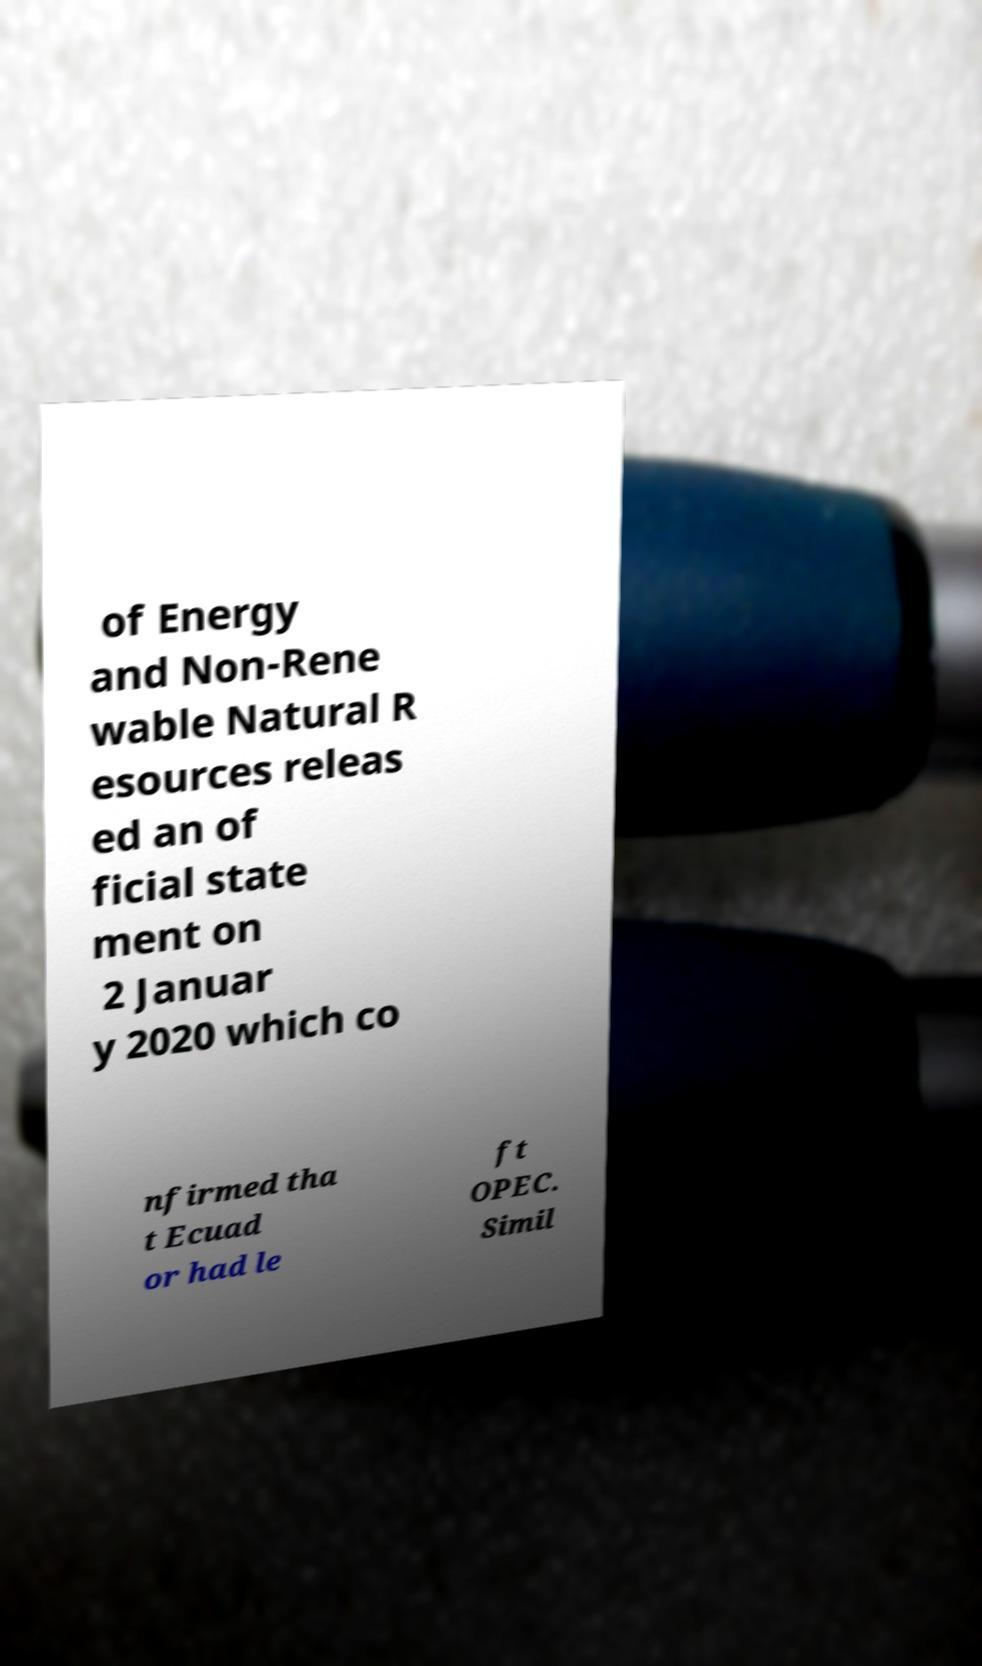Please identify and transcribe the text found in this image. of Energy and Non-Rene wable Natural R esources releas ed an of ficial state ment on 2 Januar y 2020 which co nfirmed tha t Ecuad or had le ft OPEC. Simil 